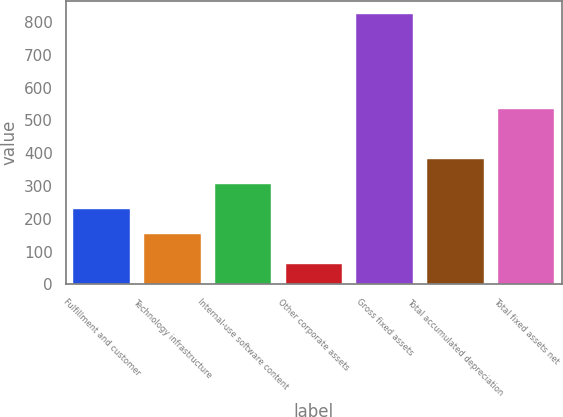Convert chart to OTSL. <chart><loc_0><loc_0><loc_500><loc_500><bar_chart><fcel>Fulfillment and customer<fcel>Technology infrastructure<fcel>Internal-use software content<fcel>Other corporate assets<fcel>Gross fixed assets<fcel>Total accumulated depreciation<fcel>Total fixed assets net<nl><fcel>229.2<fcel>153<fcel>305.4<fcel>62<fcel>824<fcel>381.6<fcel>534<nl></chart> 